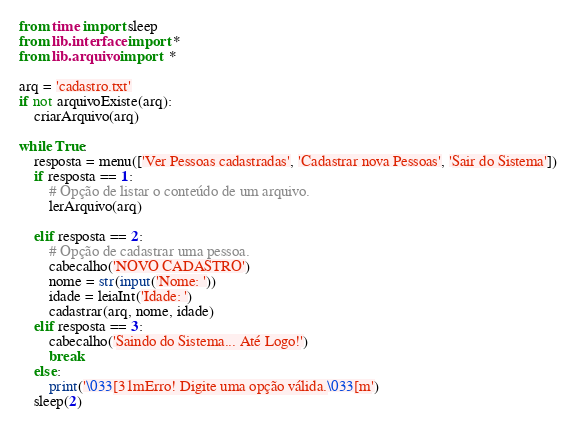<code> <loc_0><loc_0><loc_500><loc_500><_Python_>from time import sleep
from lib.interface import *
from lib.arquivo import  *

arq = 'cadastro.txt'
if not arquivoExiste(arq):
    criarArquivo(arq)

while True:
    resposta = menu(['Ver Pessoas cadastradas', 'Cadastrar nova Pessoas', 'Sair do Sistema'])
    if resposta == 1:
        # Opção de listar o conteúdo de um arquivo.
        lerArquivo(arq)

    elif resposta == 2:
        # Opção de cadastrar uma pessoa.
        cabecalho('NOVO CADASTRO')
        nome = str(input('Nome: '))
        idade = leiaInt('Idade: ')
        cadastrar(arq, nome, idade)
    elif resposta == 3:
        cabecalho('Saindo do Sistema... Até Logo!')
        break
    else:
        print('\033[31mErro! Digite uma opção válida.\033[m')
    sleep(2)


</code> 